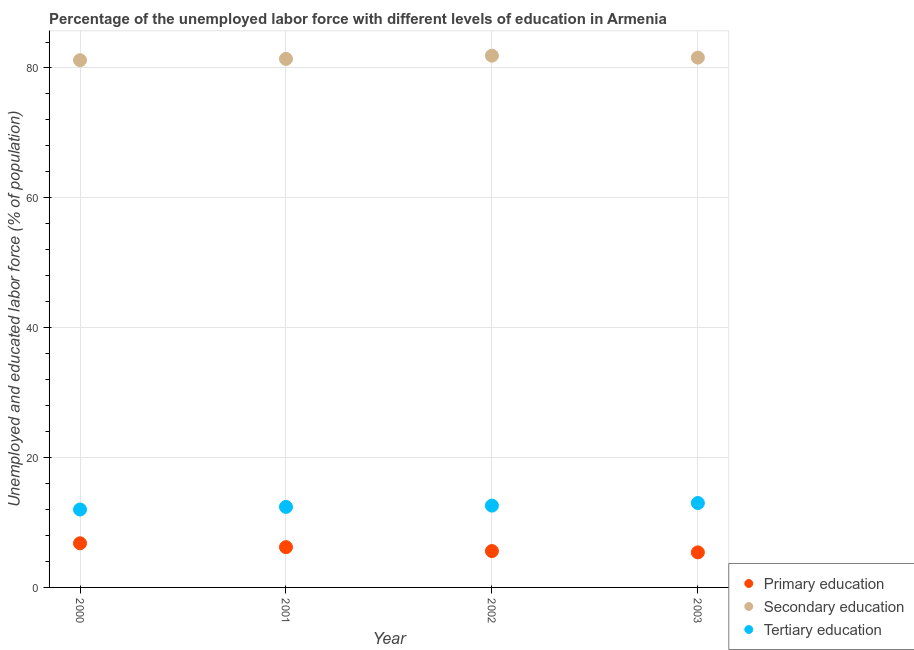What is the percentage of labor force who received secondary education in 2003?
Your answer should be compact. 81.6. Across all years, what is the maximum percentage of labor force who received secondary education?
Provide a succinct answer. 81.9. What is the total percentage of labor force who received secondary education in the graph?
Provide a succinct answer. 326.1. What is the difference between the percentage of labor force who received primary education in 2000 and that in 2002?
Keep it short and to the point. 1.2. What is the difference between the percentage of labor force who received tertiary education in 2003 and the percentage of labor force who received primary education in 2000?
Provide a succinct answer. 6.2. What is the average percentage of labor force who received secondary education per year?
Make the answer very short. 81.52. In the year 2003, what is the difference between the percentage of labor force who received primary education and percentage of labor force who received secondary education?
Provide a succinct answer. -76.2. What is the ratio of the percentage of labor force who received secondary education in 2001 to that in 2003?
Offer a terse response. 1. Is the percentage of labor force who received secondary education in 2002 less than that in 2003?
Your answer should be very brief. No. Is the difference between the percentage of labor force who received primary education in 2000 and 2001 greater than the difference between the percentage of labor force who received secondary education in 2000 and 2001?
Give a very brief answer. Yes. What is the difference between the highest and the second highest percentage of labor force who received tertiary education?
Your answer should be very brief. 0.4. What is the difference between the highest and the lowest percentage of labor force who received secondary education?
Your answer should be very brief. 0.7. In how many years, is the percentage of labor force who received secondary education greater than the average percentage of labor force who received secondary education taken over all years?
Your answer should be compact. 2. How many dotlines are there?
Make the answer very short. 3. What is the difference between two consecutive major ticks on the Y-axis?
Provide a short and direct response. 20. Are the values on the major ticks of Y-axis written in scientific E-notation?
Your response must be concise. No. Does the graph contain any zero values?
Your answer should be very brief. No. Where does the legend appear in the graph?
Offer a very short reply. Bottom right. How many legend labels are there?
Provide a succinct answer. 3. What is the title of the graph?
Give a very brief answer. Percentage of the unemployed labor force with different levels of education in Armenia. Does "Transport services" appear as one of the legend labels in the graph?
Your answer should be very brief. No. What is the label or title of the Y-axis?
Offer a terse response. Unemployed and educated labor force (% of population). What is the Unemployed and educated labor force (% of population) of Primary education in 2000?
Give a very brief answer. 6.8. What is the Unemployed and educated labor force (% of population) in Secondary education in 2000?
Make the answer very short. 81.2. What is the Unemployed and educated labor force (% of population) in Tertiary education in 2000?
Your response must be concise. 12. What is the Unemployed and educated labor force (% of population) in Primary education in 2001?
Provide a short and direct response. 6.2. What is the Unemployed and educated labor force (% of population) of Secondary education in 2001?
Your response must be concise. 81.4. What is the Unemployed and educated labor force (% of population) in Tertiary education in 2001?
Provide a short and direct response. 12.4. What is the Unemployed and educated labor force (% of population) of Primary education in 2002?
Your response must be concise. 5.6. What is the Unemployed and educated labor force (% of population) of Secondary education in 2002?
Your answer should be very brief. 81.9. What is the Unemployed and educated labor force (% of population) in Tertiary education in 2002?
Ensure brevity in your answer.  12.6. What is the Unemployed and educated labor force (% of population) of Primary education in 2003?
Your response must be concise. 5.4. What is the Unemployed and educated labor force (% of population) of Secondary education in 2003?
Provide a succinct answer. 81.6. Across all years, what is the maximum Unemployed and educated labor force (% of population) in Primary education?
Offer a very short reply. 6.8. Across all years, what is the maximum Unemployed and educated labor force (% of population) of Secondary education?
Your response must be concise. 81.9. Across all years, what is the minimum Unemployed and educated labor force (% of population) in Primary education?
Give a very brief answer. 5.4. Across all years, what is the minimum Unemployed and educated labor force (% of population) of Secondary education?
Ensure brevity in your answer.  81.2. What is the total Unemployed and educated labor force (% of population) in Secondary education in the graph?
Keep it short and to the point. 326.1. What is the difference between the Unemployed and educated labor force (% of population) in Primary education in 2000 and that in 2001?
Offer a very short reply. 0.6. What is the difference between the Unemployed and educated labor force (% of population) in Secondary education in 2000 and that in 2001?
Provide a succinct answer. -0.2. What is the difference between the Unemployed and educated labor force (% of population) in Tertiary education in 2000 and that in 2001?
Provide a succinct answer. -0.4. What is the difference between the Unemployed and educated labor force (% of population) of Tertiary education in 2000 and that in 2002?
Your answer should be compact. -0.6. What is the difference between the Unemployed and educated labor force (% of population) of Secondary education in 2000 and that in 2003?
Keep it short and to the point. -0.4. What is the difference between the Unemployed and educated labor force (% of population) of Primary education in 2001 and that in 2003?
Your answer should be compact. 0.8. What is the difference between the Unemployed and educated labor force (% of population) of Secondary education in 2001 and that in 2003?
Provide a succinct answer. -0.2. What is the difference between the Unemployed and educated labor force (% of population) of Tertiary education in 2001 and that in 2003?
Offer a very short reply. -0.6. What is the difference between the Unemployed and educated labor force (% of population) of Primary education in 2000 and the Unemployed and educated labor force (% of population) of Secondary education in 2001?
Ensure brevity in your answer.  -74.6. What is the difference between the Unemployed and educated labor force (% of population) in Primary education in 2000 and the Unemployed and educated labor force (% of population) in Tertiary education in 2001?
Give a very brief answer. -5.6. What is the difference between the Unemployed and educated labor force (% of population) of Secondary education in 2000 and the Unemployed and educated labor force (% of population) of Tertiary education in 2001?
Ensure brevity in your answer.  68.8. What is the difference between the Unemployed and educated labor force (% of population) in Primary education in 2000 and the Unemployed and educated labor force (% of population) in Secondary education in 2002?
Offer a very short reply. -75.1. What is the difference between the Unemployed and educated labor force (% of population) in Primary education in 2000 and the Unemployed and educated labor force (% of population) in Tertiary education in 2002?
Provide a short and direct response. -5.8. What is the difference between the Unemployed and educated labor force (% of population) of Secondary education in 2000 and the Unemployed and educated labor force (% of population) of Tertiary education in 2002?
Your response must be concise. 68.6. What is the difference between the Unemployed and educated labor force (% of population) in Primary education in 2000 and the Unemployed and educated labor force (% of population) in Secondary education in 2003?
Your response must be concise. -74.8. What is the difference between the Unemployed and educated labor force (% of population) in Secondary education in 2000 and the Unemployed and educated labor force (% of population) in Tertiary education in 2003?
Provide a succinct answer. 68.2. What is the difference between the Unemployed and educated labor force (% of population) in Primary education in 2001 and the Unemployed and educated labor force (% of population) in Secondary education in 2002?
Provide a succinct answer. -75.7. What is the difference between the Unemployed and educated labor force (% of population) of Secondary education in 2001 and the Unemployed and educated labor force (% of population) of Tertiary education in 2002?
Give a very brief answer. 68.8. What is the difference between the Unemployed and educated labor force (% of population) in Primary education in 2001 and the Unemployed and educated labor force (% of population) in Secondary education in 2003?
Your answer should be compact. -75.4. What is the difference between the Unemployed and educated labor force (% of population) in Secondary education in 2001 and the Unemployed and educated labor force (% of population) in Tertiary education in 2003?
Keep it short and to the point. 68.4. What is the difference between the Unemployed and educated labor force (% of population) of Primary education in 2002 and the Unemployed and educated labor force (% of population) of Secondary education in 2003?
Keep it short and to the point. -76. What is the difference between the Unemployed and educated labor force (% of population) of Primary education in 2002 and the Unemployed and educated labor force (% of population) of Tertiary education in 2003?
Your answer should be compact. -7.4. What is the difference between the Unemployed and educated labor force (% of population) in Secondary education in 2002 and the Unemployed and educated labor force (% of population) in Tertiary education in 2003?
Your response must be concise. 68.9. What is the average Unemployed and educated labor force (% of population) in Primary education per year?
Your answer should be compact. 6. What is the average Unemployed and educated labor force (% of population) in Secondary education per year?
Provide a succinct answer. 81.53. What is the average Unemployed and educated labor force (% of population) of Tertiary education per year?
Your answer should be compact. 12.5. In the year 2000, what is the difference between the Unemployed and educated labor force (% of population) of Primary education and Unemployed and educated labor force (% of population) of Secondary education?
Ensure brevity in your answer.  -74.4. In the year 2000, what is the difference between the Unemployed and educated labor force (% of population) of Primary education and Unemployed and educated labor force (% of population) of Tertiary education?
Your answer should be very brief. -5.2. In the year 2000, what is the difference between the Unemployed and educated labor force (% of population) in Secondary education and Unemployed and educated labor force (% of population) in Tertiary education?
Offer a terse response. 69.2. In the year 2001, what is the difference between the Unemployed and educated labor force (% of population) of Primary education and Unemployed and educated labor force (% of population) of Secondary education?
Offer a terse response. -75.2. In the year 2001, what is the difference between the Unemployed and educated labor force (% of population) in Secondary education and Unemployed and educated labor force (% of population) in Tertiary education?
Ensure brevity in your answer.  69. In the year 2002, what is the difference between the Unemployed and educated labor force (% of population) of Primary education and Unemployed and educated labor force (% of population) of Secondary education?
Make the answer very short. -76.3. In the year 2002, what is the difference between the Unemployed and educated labor force (% of population) in Primary education and Unemployed and educated labor force (% of population) in Tertiary education?
Ensure brevity in your answer.  -7. In the year 2002, what is the difference between the Unemployed and educated labor force (% of population) of Secondary education and Unemployed and educated labor force (% of population) of Tertiary education?
Offer a terse response. 69.3. In the year 2003, what is the difference between the Unemployed and educated labor force (% of population) of Primary education and Unemployed and educated labor force (% of population) of Secondary education?
Offer a very short reply. -76.2. In the year 2003, what is the difference between the Unemployed and educated labor force (% of population) of Secondary education and Unemployed and educated labor force (% of population) of Tertiary education?
Keep it short and to the point. 68.6. What is the ratio of the Unemployed and educated labor force (% of population) in Primary education in 2000 to that in 2001?
Ensure brevity in your answer.  1.1. What is the ratio of the Unemployed and educated labor force (% of population) of Secondary education in 2000 to that in 2001?
Your response must be concise. 1. What is the ratio of the Unemployed and educated labor force (% of population) in Tertiary education in 2000 to that in 2001?
Offer a very short reply. 0.97. What is the ratio of the Unemployed and educated labor force (% of population) in Primary education in 2000 to that in 2002?
Your response must be concise. 1.21. What is the ratio of the Unemployed and educated labor force (% of population) in Secondary education in 2000 to that in 2002?
Provide a short and direct response. 0.99. What is the ratio of the Unemployed and educated labor force (% of population) in Primary education in 2000 to that in 2003?
Offer a terse response. 1.26. What is the ratio of the Unemployed and educated labor force (% of population) in Secondary education in 2000 to that in 2003?
Your response must be concise. 1. What is the ratio of the Unemployed and educated labor force (% of population) in Primary education in 2001 to that in 2002?
Your response must be concise. 1.11. What is the ratio of the Unemployed and educated labor force (% of population) in Secondary education in 2001 to that in 2002?
Offer a terse response. 0.99. What is the ratio of the Unemployed and educated labor force (% of population) of Tertiary education in 2001 to that in 2002?
Offer a very short reply. 0.98. What is the ratio of the Unemployed and educated labor force (% of population) in Primary education in 2001 to that in 2003?
Keep it short and to the point. 1.15. What is the ratio of the Unemployed and educated labor force (% of population) of Tertiary education in 2001 to that in 2003?
Give a very brief answer. 0.95. What is the ratio of the Unemployed and educated labor force (% of population) of Tertiary education in 2002 to that in 2003?
Your response must be concise. 0.97. What is the difference between the highest and the second highest Unemployed and educated labor force (% of population) of Secondary education?
Provide a succinct answer. 0.3. What is the difference between the highest and the lowest Unemployed and educated labor force (% of population) of Secondary education?
Ensure brevity in your answer.  0.7. 